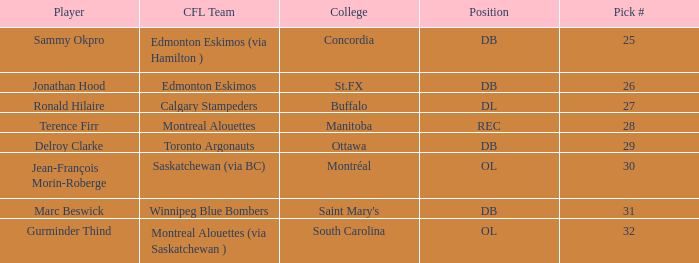Which cfl team possesses a pick # higher than 31? Montreal Alouettes (via Saskatchewan ). 